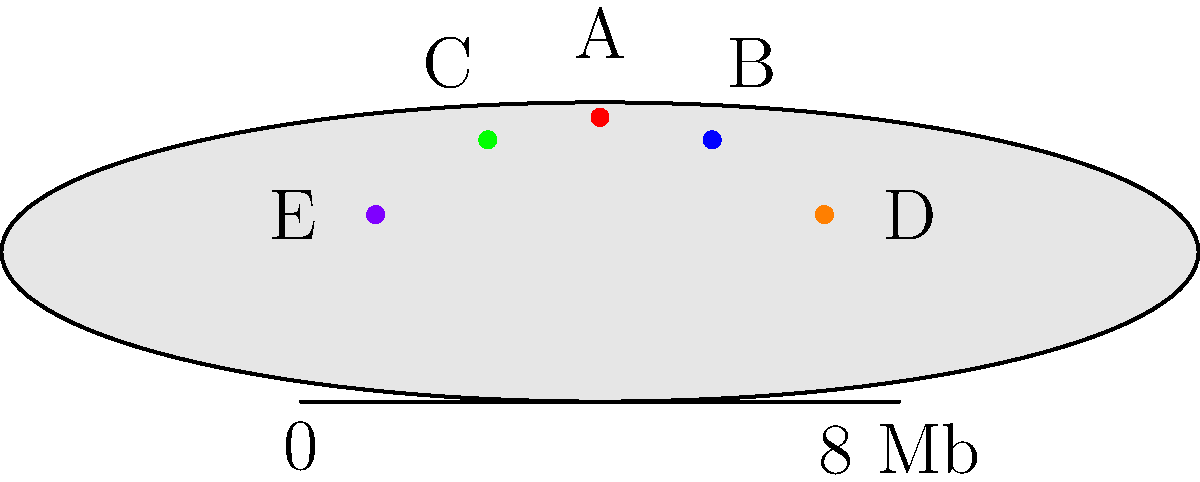A gene map of a specific chromosome is represented as an ellipse with a major axis of 8 Mb (megabases) and a minor axis of 2 Mb. Five genes (A, B, C, D, and E) are located on this chromosome. If we assume the chromosome's shape accurately represents the gene positions, what is the approximate area of the region containing all five genes in square megabases (Mb²)? To solve this problem, we'll follow these steps:

1) The chromosome is represented as an ellipse. The area of an ellipse is given by the formula:
   $A = \pi ab$
   where $a$ is half the major axis and $b$ is half the minor axis.

2) Given:
   Major axis = 8 Mb
   Minor axis = 2 Mb
   
   Therefore:
   $a = 8/2 = 4$ Mb
   $b = 2/2 = 1$ Mb

3) Substituting into the formula:
   $A = \pi (4)(1) = 4\pi$ Mb²

4) To get a numerical value, we can use $\pi \approx 3.14159$:
   $A \approx 4(3.14159) \approx 12.57$ Mb²

5) Rounding to two decimal places:
   $A \approx 12.57$ Mb²

This area represents the entire chromosome. Since all five genes are located within this area, this is the approximate area of the region containing all five genes.
Answer: 12.57 Mb² 